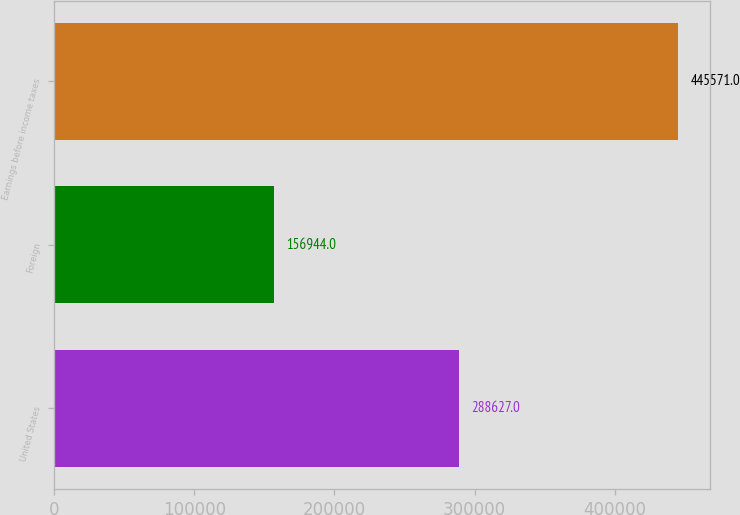Convert chart. <chart><loc_0><loc_0><loc_500><loc_500><bar_chart><fcel>United States<fcel>Foreign<fcel>Earnings before income taxes<nl><fcel>288627<fcel>156944<fcel>445571<nl></chart> 